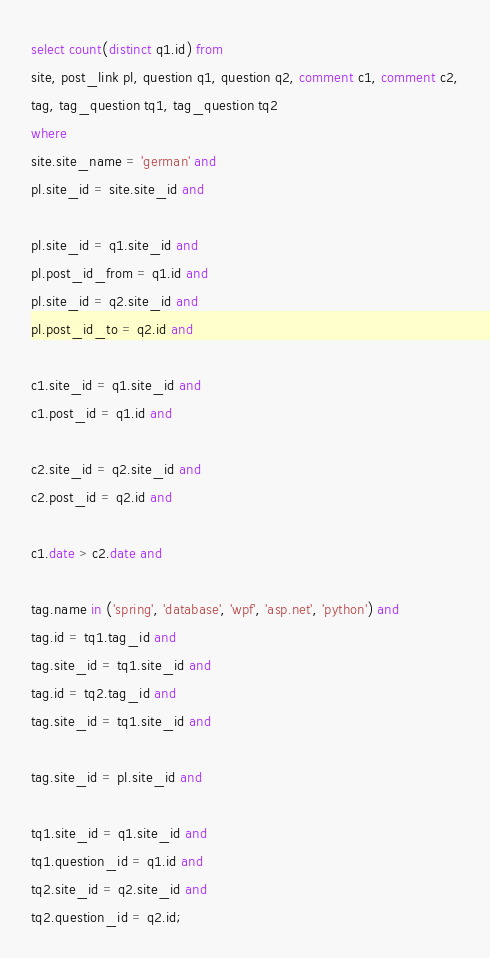Convert code to text. <code><loc_0><loc_0><loc_500><loc_500><_SQL_>
select count(distinct q1.id) from
site, post_link pl, question q1, question q2, comment c1, comment c2,
tag, tag_question tq1, tag_question tq2
where
site.site_name = 'german' and
pl.site_id = site.site_id and

pl.site_id = q1.site_id and
pl.post_id_from = q1.id and
pl.site_id = q2.site_id and
pl.post_id_to = q2.id and

c1.site_id = q1.site_id and
c1.post_id = q1.id and

c2.site_id = q2.site_id and
c2.post_id = q2.id and

c1.date > c2.date and

tag.name in ('spring', 'database', 'wpf', 'asp.net', 'python') and
tag.id = tq1.tag_id and
tag.site_id = tq1.site_id and
tag.id = tq2.tag_id and
tag.site_id = tq1.site_id and

tag.site_id = pl.site_id and

tq1.site_id = q1.site_id and
tq1.question_id = q1.id and
tq2.site_id = q2.site_id and
tq2.question_id = q2.id;

</code> 